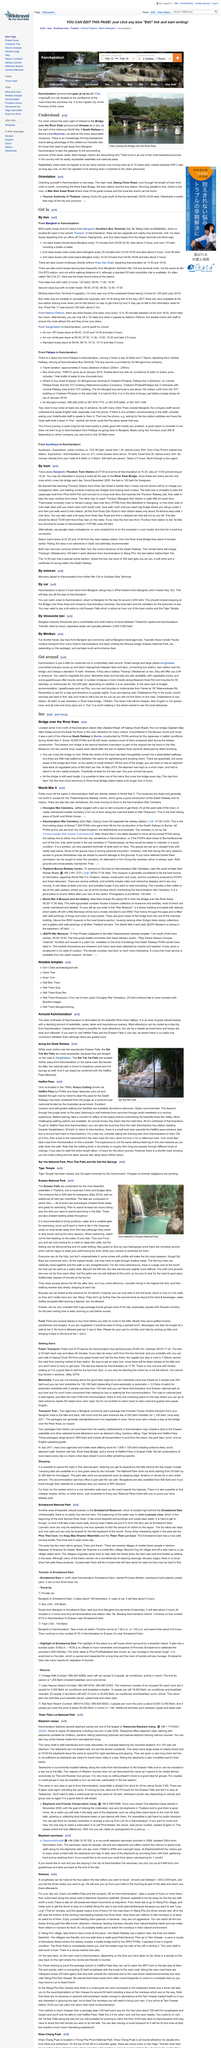Point out several critical features in this image. Burma, formerly known as Myanmar, is now officially called Myanmar. The River Kwai is the name of the river that a train crosses a bridge over in a picture. Thais, the most beautiful province in the country, is a popular destination for foreign visitors looking to escape the hustle and bustle of Bangkok. With its easily accessible waterfalls and national parks, Thais offers a tranquil and picturesque escape for those seeking to immerse themselves in nature. 